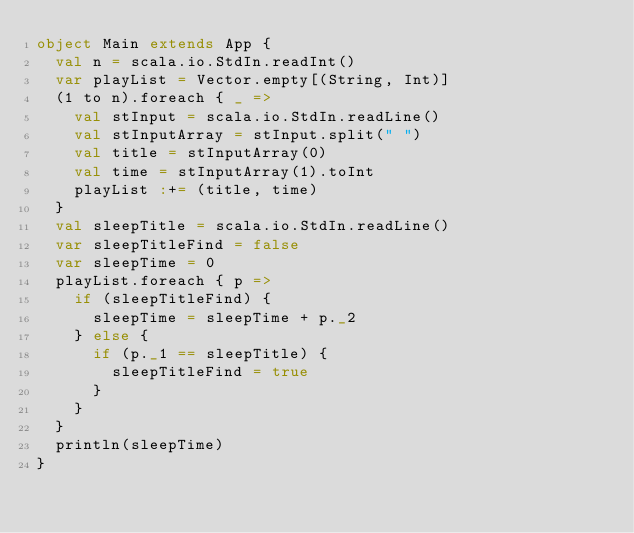Convert code to text. <code><loc_0><loc_0><loc_500><loc_500><_Scala_>object Main extends App {
  val n = scala.io.StdIn.readInt()
  var playList = Vector.empty[(String, Int)]
  (1 to n).foreach { _ =>
    val stInput = scala.io.StdIn.readLine()
    val stInputArray = stInput.split(" ")
    val title = stInputArray(0)
    val time = stInputArray(1).toInt
    playList :+= (title, time)
  }
  val sleepTitle = scala.io.StdIn.readLine()
  var sleepTitleFind = false
  var sleepTime = 0
  playList.foreach { p =>
    if (sleepTitleFind) {
      sleepTime = sleepTime + p._2
    } else {
      if (p._1 == sleepTitle) {
        sleepTitleFind = true
      }
    }
  }
  println(sleepTime)
}</code> 